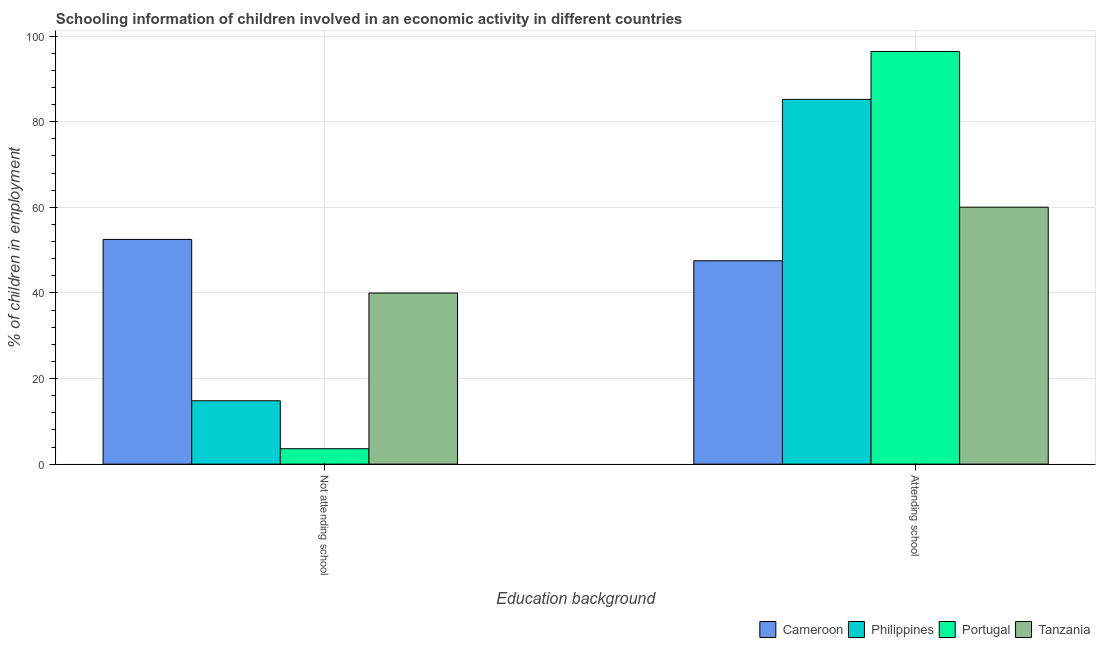Are the number of bars on each tick of the X-axis equal?
Give a very brief answer. Yes. How many bars are there on the 2nd tick from the left?
Ensure brevity in your answer.  4. What is the label of the 2nd group of bars from the left?
Offer a very short reply. Attending school. What is the percentage of employed children who are not attending school in Philippines?
Give a very brief answer. 14.8. Across all countries, what is the maximum percentage of employed children who are not attending school?
Offer a terse response. 52.49. Across all countries, what is the minimum percentage of employed children who are attending school?
Offer a terse response. 47.51. In which country was the percentage of employed children who are not attending school maximum?
Your answer should be very brief. Cameroon. What is the total percentage of employed children who are attending school in the graph?
Your response must be concise. 289.13. What is the difference between the percentage of employed children who are not attending school in Philippines and that in Tanzania?
Give a very brief answer. -25.18. What is the difference between the percentage of employed children who are not attending school in Philippines and the percentage of employed children who are attending school in Portugal?
Offer a very short reply. -81.6. What is the average percentage of employed children who are not attending school per country?
Provide a succinct answer. 27.72. What is the difference between the percentage of employed children who are not attending school and percentage of employed children who are attending school in Portugal?
Keep it short and to the point. -92.79. In how many countries, is the percentage of employed children who are attending school greater than 60 %?
Offer a terse response. 3. What is the ratio of the percentage of employed children who are not attending school in Portugal to that in Cameroon?
Offer a very short reply. 0.07. Is the percentage of employed children who are attending school in Portugal less than that in Philippines?
Ensure brevity in your answer.  No. What does the 4th bar from the left in Not attending school represents?
Offer a very short reply. Tanzania. What does the 3rd bar from the right in Not attending school represents?
Offer a terse response. Philippines. What is the difference between two consecutive major ticks on the Y-axis?
Provide a succinct answer. 20. Does the graph contain grids?
Your answer should be compact. Yes. Where does the legend appear in the graph?
Your answer should be compact. Bottom right. What is the title of the graph?
Provide a short and direct response. Schooling information of children involved in an economic activity in different countries. Does "Bermuda" appear as one of the legend labels in the graph?
Provide a short and direct response. No. What is the label or title of the X-axis?
Make the answer very short. Education background. What is the label or title of the Y-axis?
Your response must be concise. % of children in employment. What is the % of children in employment of Cameroon in Not attending school?
Your response must be concise. 52.49. What is the % of children in employment in Philippines in Not attending school?
Provide a succinct answer. 14.8. What is the % of children in employment in Portugal in Not attending school?
Offer a terse response. 3.6. What is the % of children in employment of Tanzania in Not attending school?
Offer a terse response. 39.98. What is the % of children in employment in Cameroon in Attending school?
Offer a terse response. 47.51. What is the % of children in employment in Philippines in Attending school?
Offer a terse response. 85.2. What is the % of children in employment of Portugal in Attending school?
Provide a short and direct response. 96.4. What is the % of children in employment of Tanzania in Attending school?
Keep it short and to the point. 60.02. Across all Education background, what is the maximum % of children in employment in Cameroon?
Make the answer very short. 52.49. Across all Education background, what is the maximum % of children in employment of Philippines?
Provide a short and direct response. 85.2. Across all Education background, what is the maximum % of children in employment of Portugal?
Provide a short and direct response. 96.4. Across all Education background, what is the maximum % of children in employment of Tanzania?
Keep it short and to the point. 60.02. Across all Education background, what is the minimum % of children in employment in Cameroon?
Provide a succinct answer. 47.51. Across all Education background, what is the minimum % of children in employment of Philippines?
Your answer should be compact. 14.8. Across all Education background, what is the minimum % of children in employment of Portugal?
Your response must be concise. 3.6. Across all Education background, what is the minimum % of children in employment of Tanzania?
Offer a terse response. 39.98. What is the total % of children in employment in Cameroon in the graph?
Offer a very short reply. 100. What is the total % of children in employment in Portugal in the graph?
Your answer should be very brief. 100. What is the total % of children in employment in Tanzania in the graph?
Your answer should be very brief. 100. What is the difference between the % of children in employment of Cameroon in Not attending school and that in Attending school?
Offer a terse response. 4.99. What is the difference between the % of children in employment in Philippines in Not attending school and that in Attending school?
Offer a terse response. -70.4. What is the difference between the % of children in employment of Portugal in Not attending school and that in Attending school?
Give a very brief answer. -92.79. What is the difference between the % of children in employment of Tanzania in Not attending school and that in Attending school?
Offer a very short reply. -20.05. What is the difference between the % of children in employment in Cameroon in Not attending school and the % of children in employment in Philippines in Attending school?
Make the answer very short. -32.71. What is the difference between the % of children in employment of Cameroon in Not attending school and the % of children in employment of Portugal in Attending school?
Provide a succinct answer. -43.9. What is the difference between the % of children in employment of Cameroon in Not attending school and the % of children in employment of Tanzania in Attending school?
Make the answer very short. -7.53. What is the difference between the % of children in employment in Philippines in Not attending school and the % of children in employment in Portugal in Attending school?
Provide a short and direct response. -81.6. What is the difference between the % of children in employment in Philippines in Not attending school and the % of children in employment in Tanzania in Attending school?
Provide a succinct answer. -45.23. What is the difference between the % of children in employment in Portugal in Not attending school and the % of children in employment in Tanzania in Attending school?
Offer a terse response. -56.42. What is the average % of children in employment in Cameroon per Education background?
Your response must be concise. 50. What is the average % of children in employment in Philippines per Education background?
Offer a very short reply. 50. What is the average % of children in employment of Tanzania per Education background?
Offer a very short reply. 50. What is the difference between the % of children in employment in Cameroon and % of children in employment in Philippines in Not attending school?
Give a very brief answer. 37.7. What is the difference between the % of children in employment of Cameroon and % of children in employment of Portugal in Not attending school?
Make the answer very short. 48.89. What is the difference between the % of children in employment of Cameroon and % of children in employment of Tanzania in Not attending school?
Your response must be concise. 12.52. What is the difference between the % of children in employment in Philippines and % of children in employment in Portugal in Not attending school?
Offer a terse response. 11.19. What is the difference between the % of children in employment of Philippines and % of children in employment of Tanzania in Not attending school?
Ensure brevity in your answer.  -25.18. What is the difference between the % of children in employment in Portugal and % of children in employment in Tanzania in Not attending school?
Provide a short and direct response. -36.37. What is the difference between the % of children in employment of Cameroon and % of children in employment of Philippines in Attending school?
Provide a short and direct response. -37.69. What is the difference between the % of children in employment in Cameroon and % of children in employment in Portugal in Attending school?
Your answer should be compact. -48.89. What is the difference between the % of children in employment in Cameroon and % of children in employment in Tanzania in Attending school?
Give a very brief answer. -12.52. What is the difference between the % of children in employment of Philippines and % of children in employment of Portugal in Attending school?
Keep it short and to the point. -11.19. What is the difference between the % of children in employment of Philippines and % of children in employment of Tanzania in Attending school?
Make the answer very short. 25.18. What is the difference between the % of children in employment in Portugal and % of children in employment in Tanzania in Attending school?
Ensure brevity in your answer.  36.37. What is the ratio of the % of children in employment of Cameroon in Not attending school to that in Attending school?
Offer a very short reply. 1.1. What is the ratio of the % of children in employment in Philippines in Not attending school to that in Attending school?
Keep it short and to the point. 0.17. What is the ratio of the % of children in employment in Portugal in Not attending school to that in Attending school?
Provide a short and direct response. 0.04. What is the ratio of the % of children in employment in Tanzania in Not attending school to that in Attending school?
Ensure brevity in your answer.  0.67. What is the difference between the highest and the second highest % of children in employment in Cameroon?
Keep it short and to the point. 4.99. What is the difference between the highest and the second highest % of children in employment in Philippines?
Offer a terse response. 70.4. What is the difference between the highest and the second highest % of children in employment of Portugal?
Ensure brevity in your answer.  92.79. What is the difference between the highest and the second highest % of children in employment in Tanzania?
Provide a succinct answer. 20.05. What is the difference between the highest and the lowest % of children in employment in Cameroon?
Provide a short and direct response. 4.99. What is the difference between the highest and the lowest % of children in employment in Philippines?
Ensure brevity in your answer.  70.4. What is the difference between the highest and the lowest % of children in employment of Portugal?
Offer a very short reply. 92.79. What is the difference between the highest and the lowest % of children in employment of Tanzania?
Make the answer very short. 20.05. 